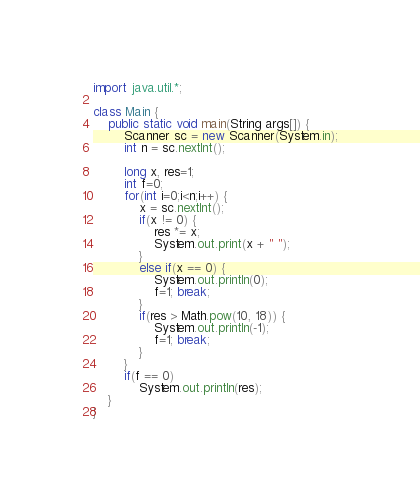<code> <loc_0><loc_0><loc_500><loc_500><_Java_>import java.util.*;

class Main {
    public static void main(String args[]) {
        Scanner sc = new Scanner(System.in);
        int n = sc.nextInt();
        
        long x, res=1;
        int f=0;
        for(int i=0;i<n;i++) {
            x = sc.nextInt();
            if(x != 0) {
                res *= x;
                System.out.print(x + " ");
            }
            else if(x == 0) {
                System.out.println(0);
                f=1; break;
            }
            if(res > Math.pow(10, 18)) {
                System.out.println(-1);
                f=1; break;
            }
        }
        if(f == 0)
            System.out.println(res);
    }
}</code> 